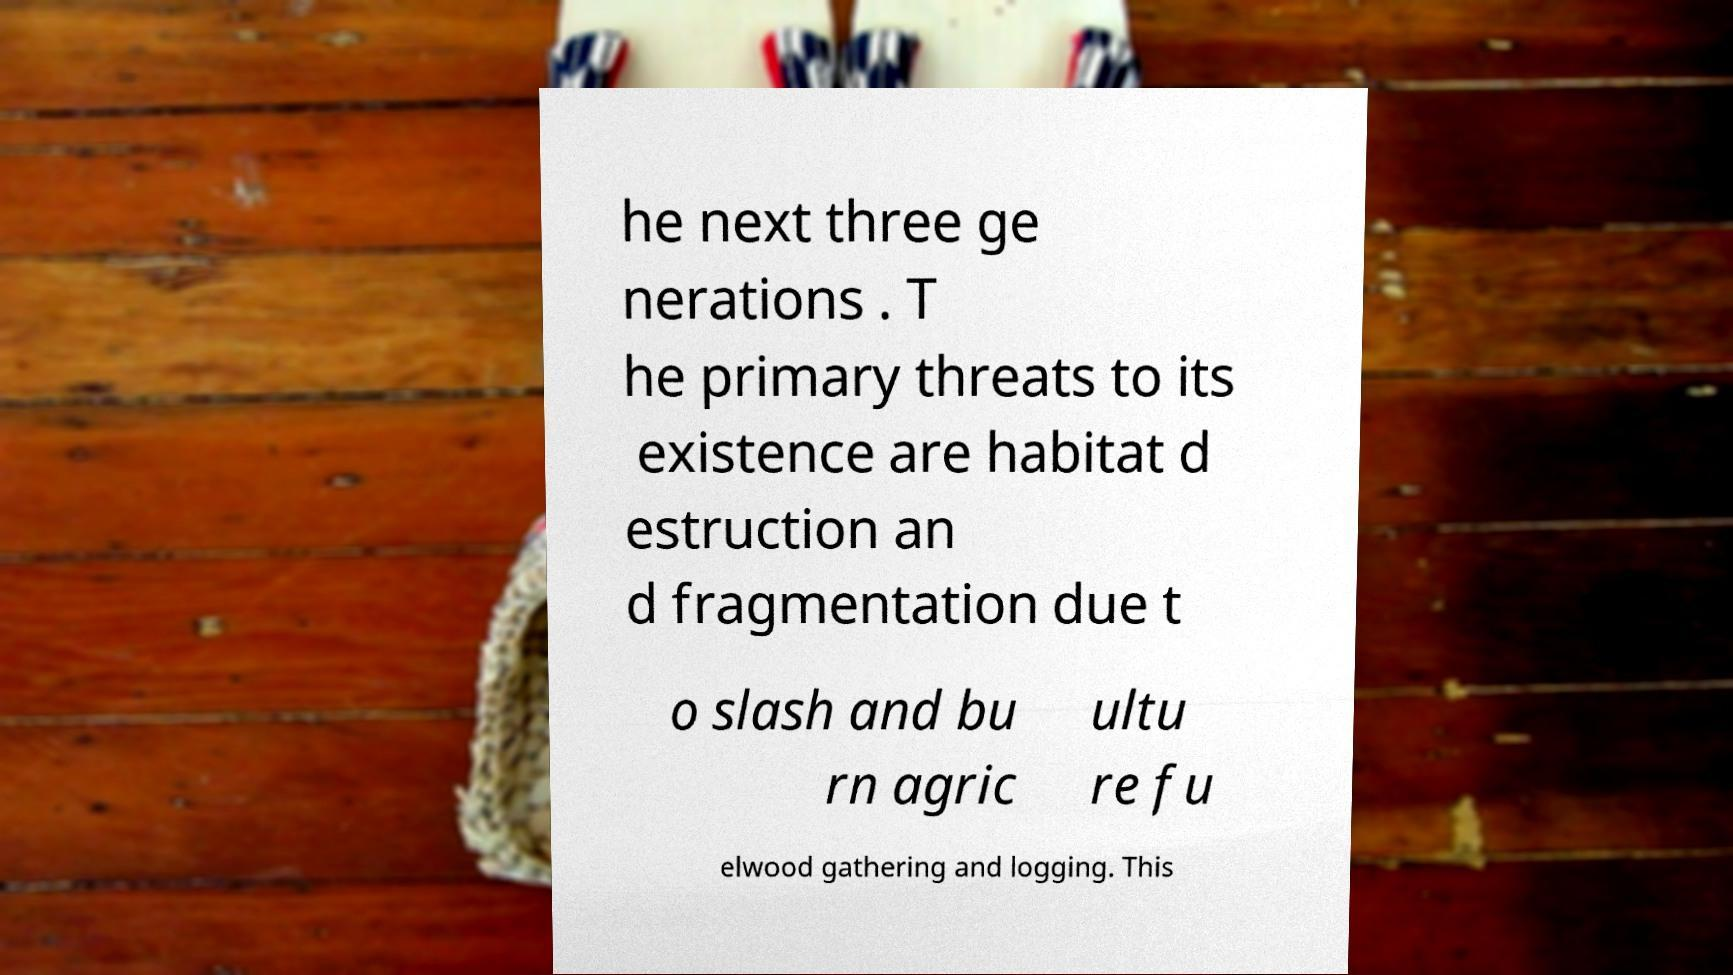Please read and relay the text visible in this image. What does it say? he next three ge nerations . T he primary threats to its existence are habitat d estruction an d fragmentation due t o slash and bu rn agric ultu re fu elwood gathering and logging. This 